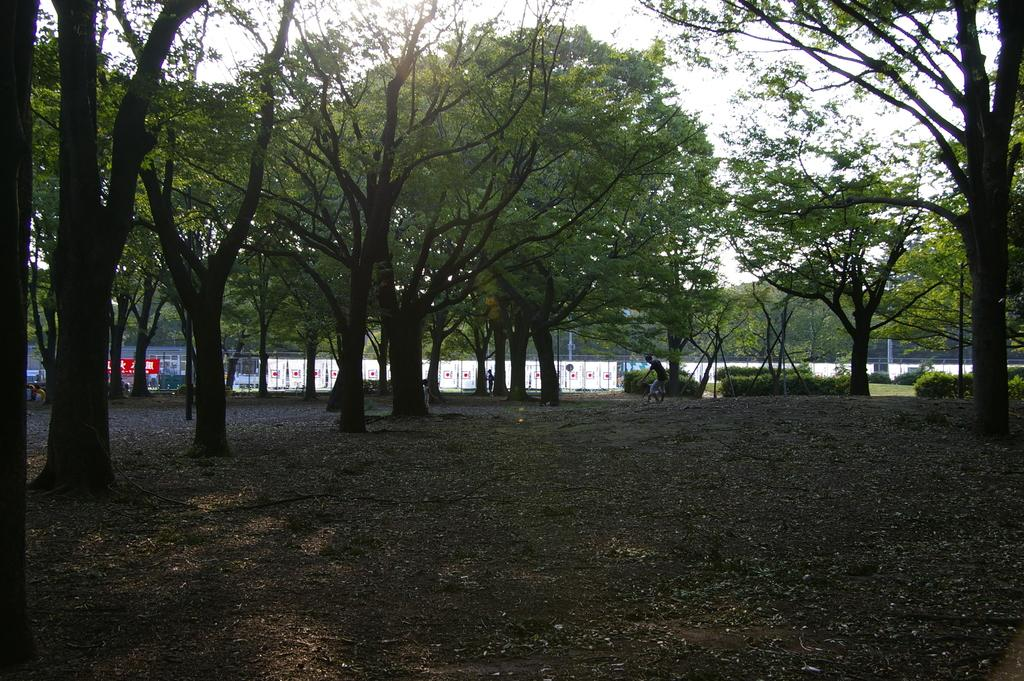Who or what is present in the image? There is a person in the image. What can be seen in the background of the image? There are trees, boards, poles, a fence, and plants in the background of the image. What is visible at the bottom of the image? The ground is visible at the bottom of the image. What type of agreement is being discussed in the image? There is no indication of an agreement being discussed in the image. --- Facts: 1. There is a person holding a book in the image. 2. The person is sitting on a chair. 3. There is a table in the image. 4. The table has a lamp on it. 5. The background of the image is a room. Absurd Topics: ocean, dance, rainbow Conversation: What is the person in the image holding? The person in the image is holding a book. What is the person sitting on? The person is sitting on a chair. What else can be seen in the image? There is a table in the image, and it has a lamp on it. What is the setting of the image? The background of the image is a room. Reasoning: Let's think step by step in order to produce the conversation. We start by identifying the main subject in the image, which is the person holding a book. Then, we describe the person's actions and the objects they are interacting with, such as the chair and the table with a lamp on it. Finally, we describe the setting of the image, which is a room. Absurd Question/Answer: Can you see a rainbow in the image? No, there is no rainbow visible in the image. 